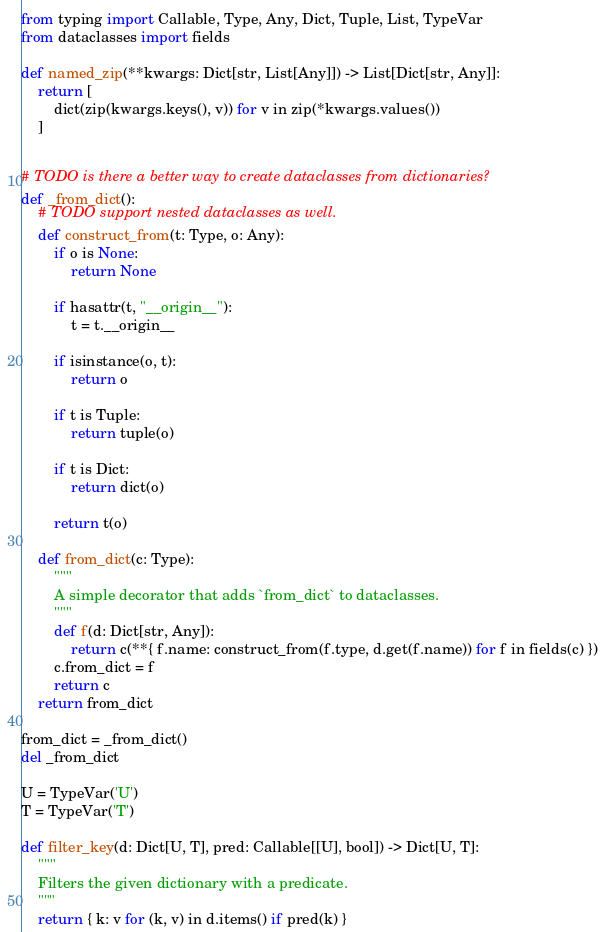Convert code to text. <code><loc_0><loc_0><loc_500><loc_500><_Python_>from typing import Callable, Type, Any, Dict, Tuple, List, TypeVar
from dataclasses import fields

def named_zip(**kwargs: Dict[str, List[Any]]) -> List[Dict[str, Any]]:
    return [
        dict(zip(kwargs.keys(), v)) for v in zip(*kwargs.values())
    ]


# TODO is there a better way to create dataclasses from dictionaries?
def _from_dict():
    # TODO support nested dataclasses as well.
    def construct_from(t: Type, o: Any):
        if o is None:
            return None
        
        if hasattr(t, "__origin__"):
            t = t.__origin__

        if isinstance(o, t):
            return o
        
        if t is Tuple:
            return tuple(o)
        
        if t is Dict:
            return dict(o)
        
        return t(o)
    
    def from_dict(c: Type):
        """
        A simple decorator that adds `from_dict` to dataclasses.
        """
        def f(d: Dict[str, Any]):
            return c(**{ f.name: construct_from(f.type, d.get(f.name)) for f in fields(c) })
        c.from_dict = f
        return c
    return from_dict

from_dict = _from_dict()
del _from_dict

U = TypeVar('U')
T = TypeVar('T')

def filter_key(d: Dict[U, T], pred: Callable[[U], bool]) -> Dict[U, T]:
    """
    Filters the given dictionary with a predicate.
    """
    return { k: v for (k, v) in d.items() if pred(k) }
</code> 